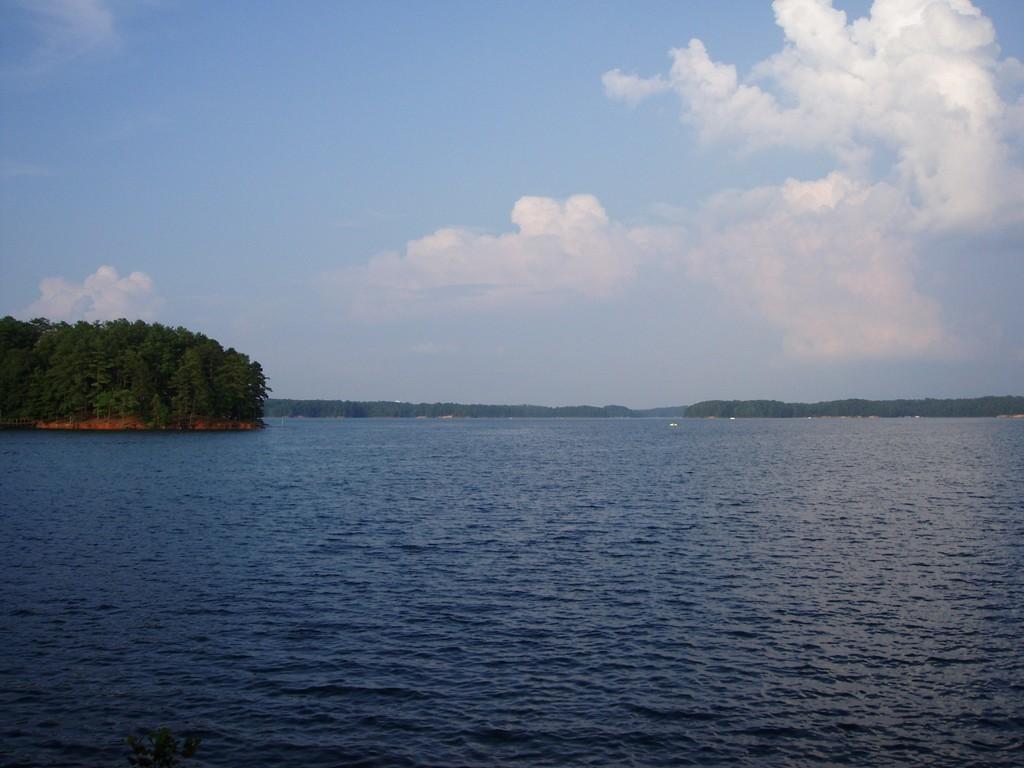Can you describe this image briefly? In this image we can see there is a river. At the center of the image there are some trees. In the background there is a sky. 